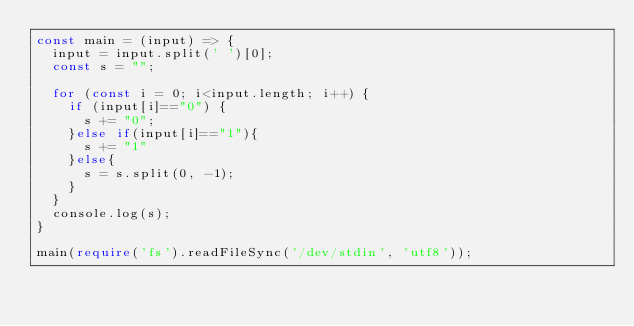<code> <loc_0><loc_0><loc_500><loc_500><_TypeScript_>const main = (input) => {
  input = input.split(' ')[0];
  const s = "";
  
  for (const i = 0; i<input.length; i++) {
    if (input[i]=="0") {
      s += "0";
    }else if(input[i]=="1"){
      s += "1"
    }else{
      s = s.split(0, -1);
    }
  }
  console.log(s);
}
 
main(require('fs').readFileSync('/dev/stdin', 'utf8'));</code> 